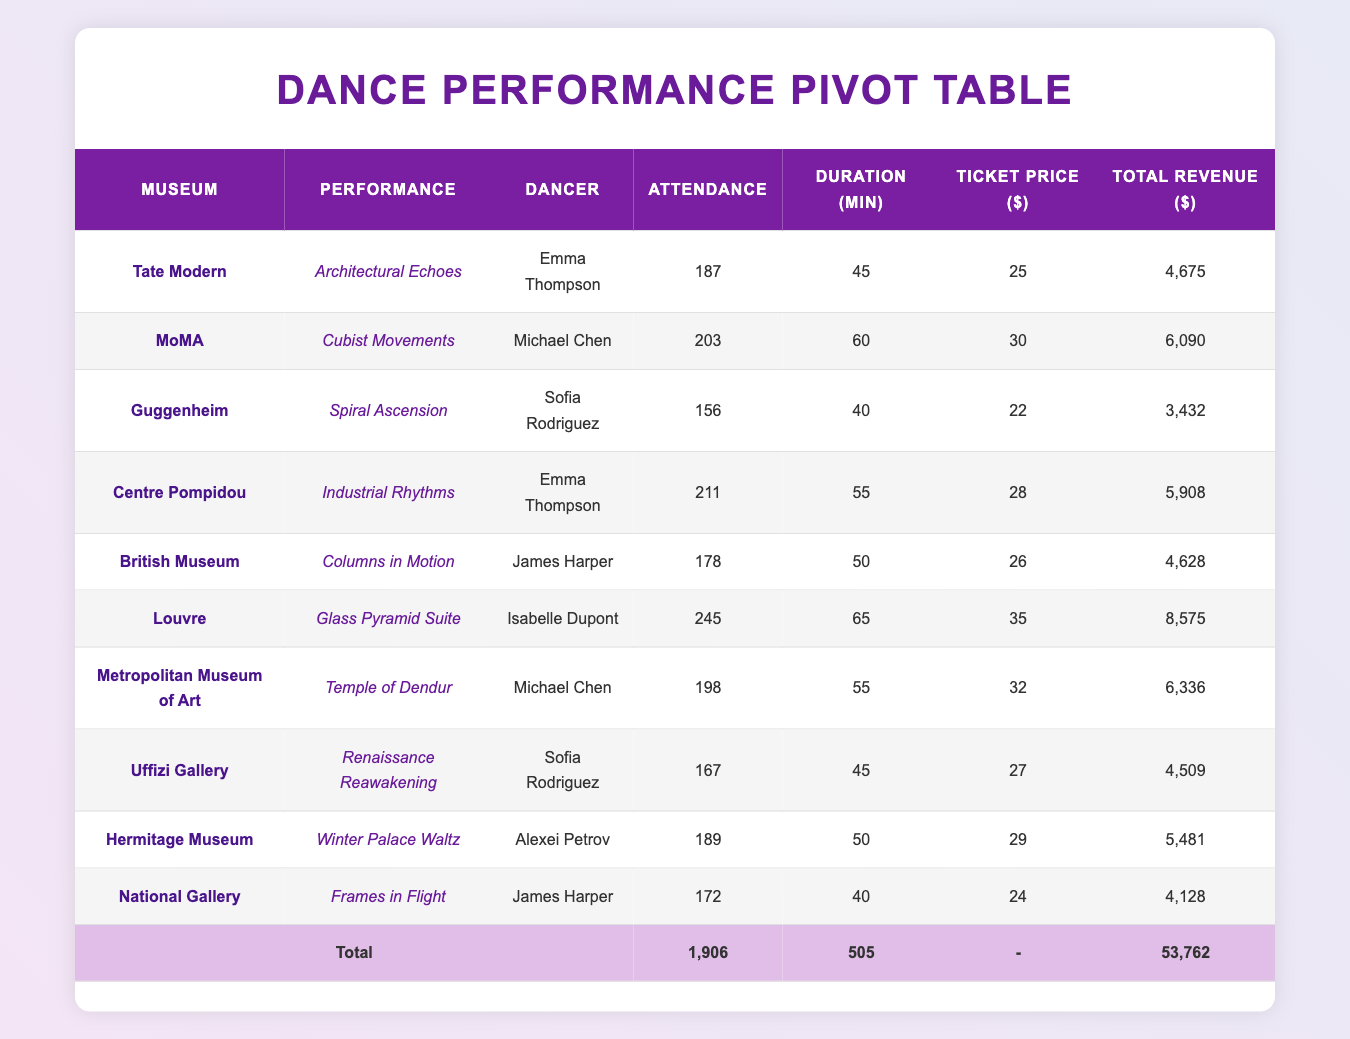What was the performance with the highest attendance? By reviewing the "Attendance" column, the highest value is 245, which corresponds to the performance "Glass Pyramid Suite" at the Louvre.
Answer: Glass Pyramid Suite Which dancer performed at the Centre Pompidou? The table lists "Emma Thompson" as the dancer for the performance "Industrial Rhythms" at the Centre Pompidou.
Answer: Emma Thompson How much total revenue was generated by all performances? To find the total revenue, we need to sum all the values in the "Total Revenue" column: 4675 + 6090 + 3432 + 5908 + 4628 + 8575 + 6336 + 4509 + 5481 + 4128 = 53762.
Answer: 53762 Did the Metropolitan Museum of Art have a higher attendance than the Guggenheim? The attendance at the Metropolitan Museum was 198, while at the Guggenheim it was 156, indicating that the Metropolitan Museum had a higher attendance.
Answer: Yes What is the average ticket price across all performances? To find the average ticket price, we sum the ticket prices (25 + 30 + 22 + 28 + 26 + 35 + 32 + 27 + 29 + 24 =  256) and divide by the count of performances (10): 256 / 10 = 25.6.
Answer: 25.6 Which performance had the shortest duration, and what was that duration? The shortest duration listed is 40 minutes for two performances: "Spiral Ascension" at the Guggenheim and "Frames in Flight" at the National Gallery.
Answer: 40 How many performances had attendance above 200? By counting the rows with attendance values greater than 200, we find three performances: "Cubist Movements," "Industrial Rhythms," and "Glass Pyramid Suite." Therefore, the count is three.
Answer: 3 What was the average attendance across all performances? We calculate the average attendance by summing all attendees (1906) and dividing by the number of performances (10): 1906 / 10 = 190.6.
Answer: 190.6 Was the ticket price for "Architectural Echoes" lower than that for "Cubist Movements"? The ticket price for "Architectural Echoes" is 25, while for "Cubist Movements," it's 30. Hence, "Architectural Echoes" had a lower ticket price.
Answer: Yes 